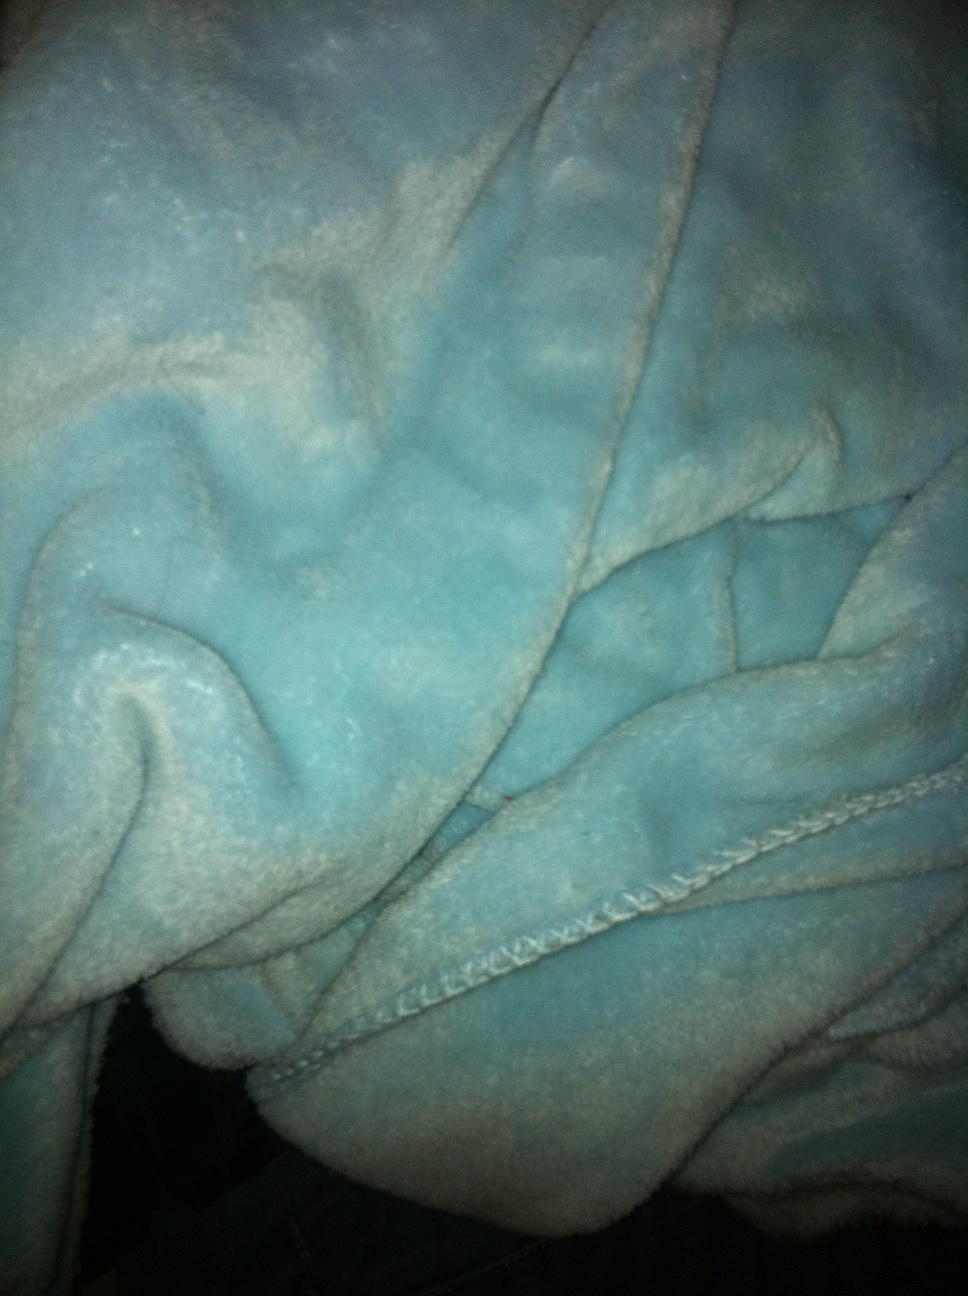What color is this bath robe? from Vizwiz blue 